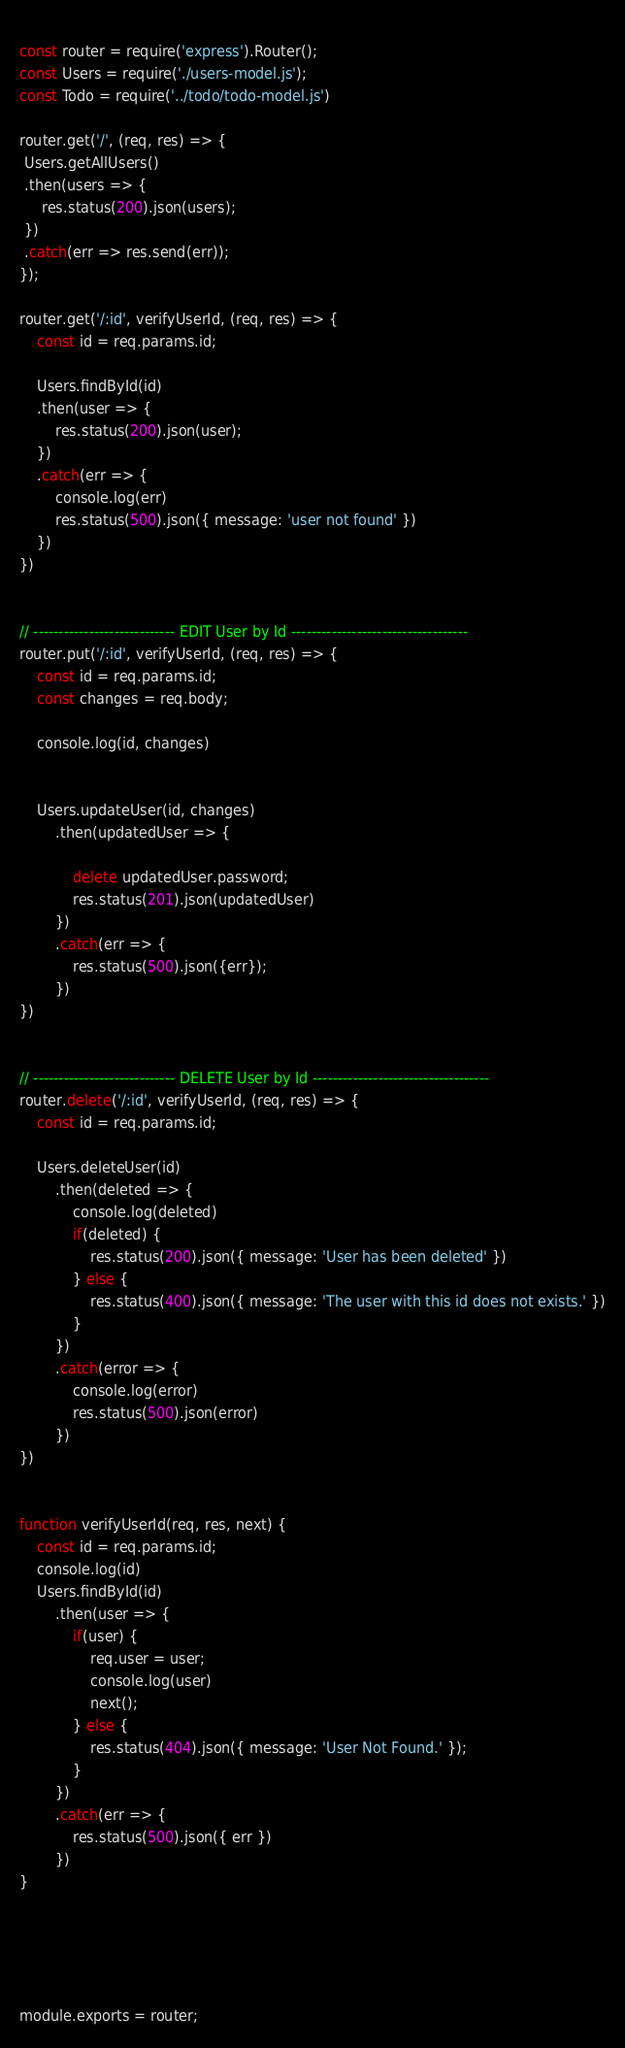<code> <loc_0><loc_0><loc_500><loc_500><_JavaScript_>  
const router = require('express').Router();
const Users = require('./users-model.js');
const Todo = require('../todo/todo-model.js')

router.get('/', (req, res) => {
 Users.getAllUsers()
 .then(users => {
     res.status(200).json(users);
 })
 .catch(err => res.send(err));
});

router.get('/:id', verifyUserId, (req, res) => {
    const id = req.params.id;

    Users.findById(id)
    .then(user => {
        res.status(200).json(user);
    })
    .catch(err => {
        console.log(err)
        res.status(500).json({ message: 'user not found' })
    })
})


// ---------------------------- EDIT User by Id -----------------------------------
router.put('/:id', verifyUserId, (req, res) => {
    const id = req.params.id;
    const changes = req.body;

    console.log(id, changes)
    

    Users.updateUser(id, changes)
        .then(updatedUser => {
        
            delete updatedUser.password;
            res.status(201).json(updatedUser)
        })
        .catch(err => {
            res.status(500).json({err});
        })
})


// ---------------------------- DELETE User by Id -----------------------------------
router.delete('/:id', verifyUserId, (req, res) => {
    const id = req.params.id;

    Users.deleteUser(id)
        .then(deleted => {
            console.log(deleted)
            if(deleted) {
                res.status(200).json({ message: 'User has been deleted' })
            } else {
                res.status(400).json({ message: 'The user with this id does not exists.' })
            }
        })
        .catch(error => {
            console.log(error)
            res.status(500).json(error)
        })
})


function verifyUserId(req, res, next) {
    const id = req.params.id;
    console.log(id)
    Users.findById(id)
        .then(user => {
            if(user) {
                req.user = user;
                console.log(user)
                next();
            } else {
                res.status(404).json({ message: 'User Not Found.' });
            }
        })
        .catch(err => {
            res.status(500).json({ err })
        })
}





module.exports = router;
</code> 